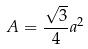Convert formula to latex. <formula><loc_0><loc_0><loc_500><loc_500>A = \frac { \sqrt { 3 } } { 4 } a ^ { 2 }</formula> 